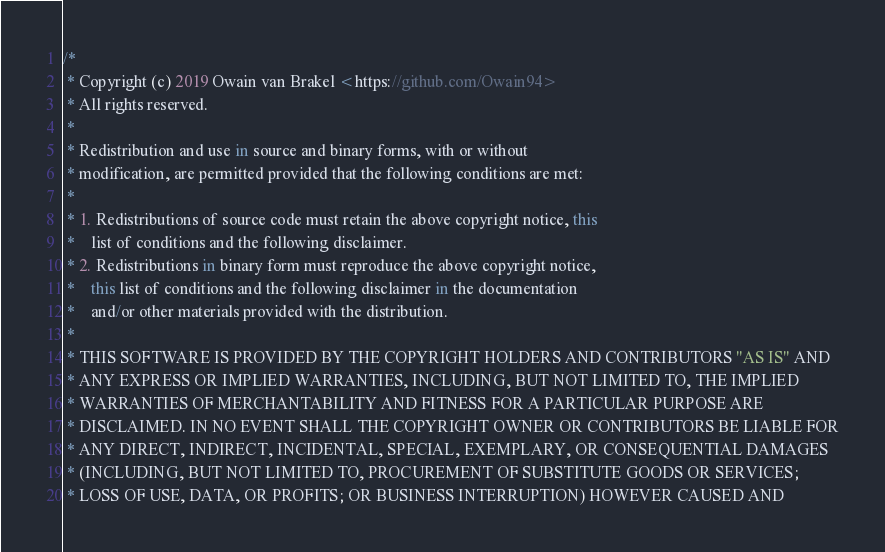<code> <loc_0><loc_0><loc_500><loc_500><_Kotlin_>/*
 * Copyright (c) 2019 Owain van Brakel <https://github.com/Owain94>
 * All rights reserved.
 *
 * Redistribution and use in source and binary forms, with or without
 * modification, are permitted provided that the following conditions are met:
 *
 * 1. Redistributions of source code must retain the above copyright notice, this
 *    list of conditions and the following disclaimer.
 * 2. Redistributions in binary form must reproduce the above copyright notice,
 *    this list of conditions and the following disclaimer in the documentation
 *    and/or other materials provided with the distribution.
 *
 * THIS SOFTWARE IS PROVIDED BY THE COPYRIGHT HOLDERS AND CONTRIBUTORS "AS IS" AND
 * ANY EXPRESS OR IMPLIED WARRANTIES, INCLUDING, BUT NOT LIMITED TO, THE IMPLIED
 * WARRANTIES OF MERCHANTABILITY AND FITNESS FOR A PARTICULAR PURPOSE ARE
 * DISCLAIMED. IN NO EVENT SHALL THE COPYRIGHT OWNER OR CONTRIBUTORS BE LIABLE FOR
 * ANY DIRECT, INDIRECT, INCIDENTAL, SPECIAL, EXEMPLARY, OR CONSEQUENTIAL DAMAGES
 * (INCLUDING, BUT NOT LIMITED TO, PROCUREMENT OF SUBSTITUTE GOODS OR SERVICES;
 * LOSS OF USE, DATA, OR PROFITS; OR BUSINESS INTERRUPTION) HOWEVER CAUSED AND</code> 